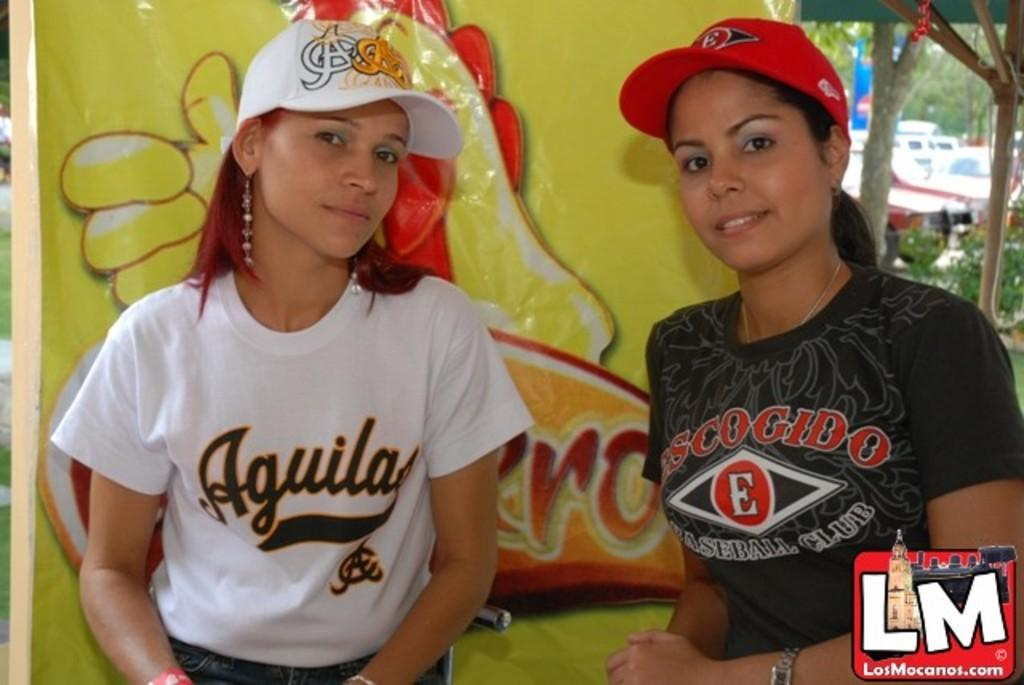How many women are in the image? There are two women in the image. What are the women wearing on their heads? The women are wearing caps. What can be seen in the background of the image? There is a banner, plants, trees, and vehicles in the background of the image. Is there any text or symbol at the bottom of the image? Yes, there is a logo at the bottom of the image. What type of punishment is being administered to the frogs in the image? There are no frogs present in the image, and therefore no punishment can be observed. 